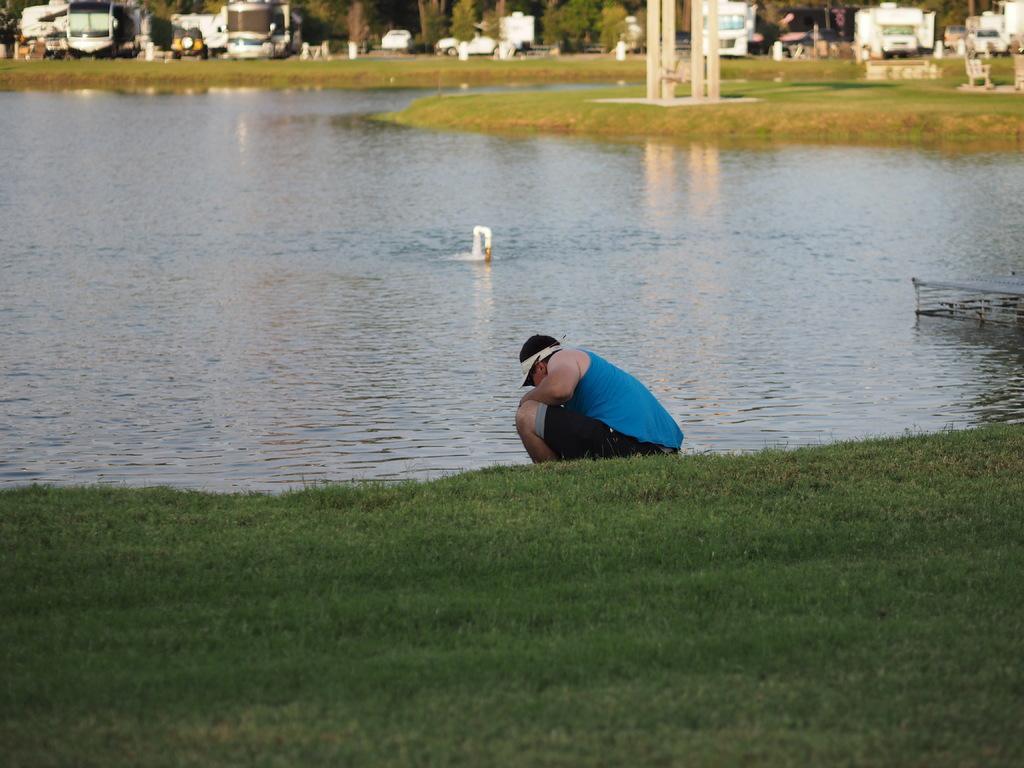Could you give a brief overview of what you see in this image? Here a person is there, this is a grass in the down side and this is water. 